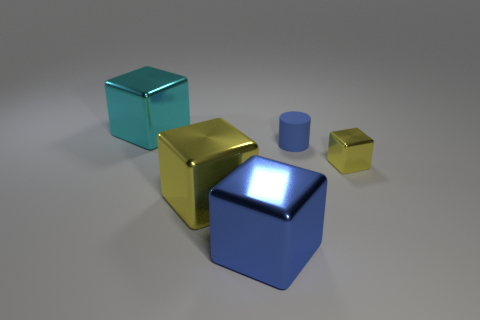Subtract all cyan shiny cubes. How many cubes are left? 3 Subtract all green balls. How many yellow cubes are left? 2 Add 4 big green cubes. How many objects exist? 9 Subtract all blue blocks. How many blocks are left? 3 Subtract all red blocks. Subtract all blue cylinders. How many blocks are left? 4 Subtract all cubes. How many objects are left? 1 Add 5 big yellow cubes. How many big yellow cubes are left? 6 Add 4 cyan blocks. How many cyan blocks exist? 5 Subtract 0 yellow cylinders. How many objects are left? 5 Subtract all small cylinders. Subtract all cyan rubber objects. How many objects are left? 4 